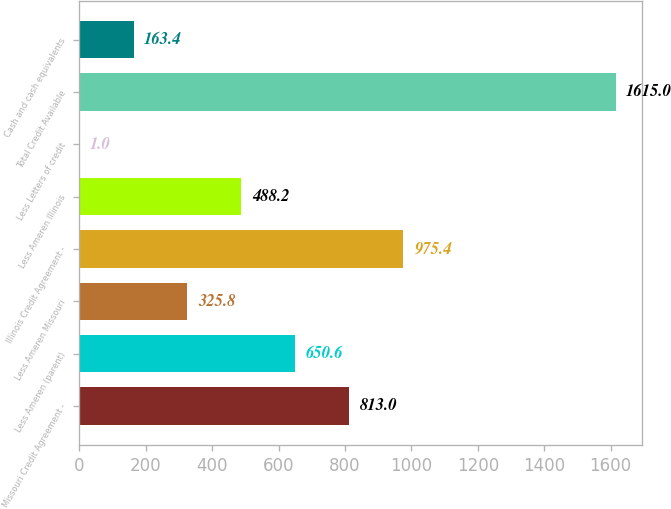Convert chart. <chart><loc_0><loc_0><loc_500><loc_500><bar_chart><fcel>Missouri Credit Agreement -<fcel>Less Ameren (parent)<fcel>Less Ameren Missouri<fcel>Illinois Credit Agreement -<fcel>Less Ameren Illinois<fcel>Less Letters of credit<fcel>Total Credit Available<fcel>Cash and cash equivalents<nl><fcel>813<fcel>650.6<fcel>325.8<fcel>975.4<fcel>488.2<fcel>1<fcel>1615<fcel>163.4<nl></chart> 